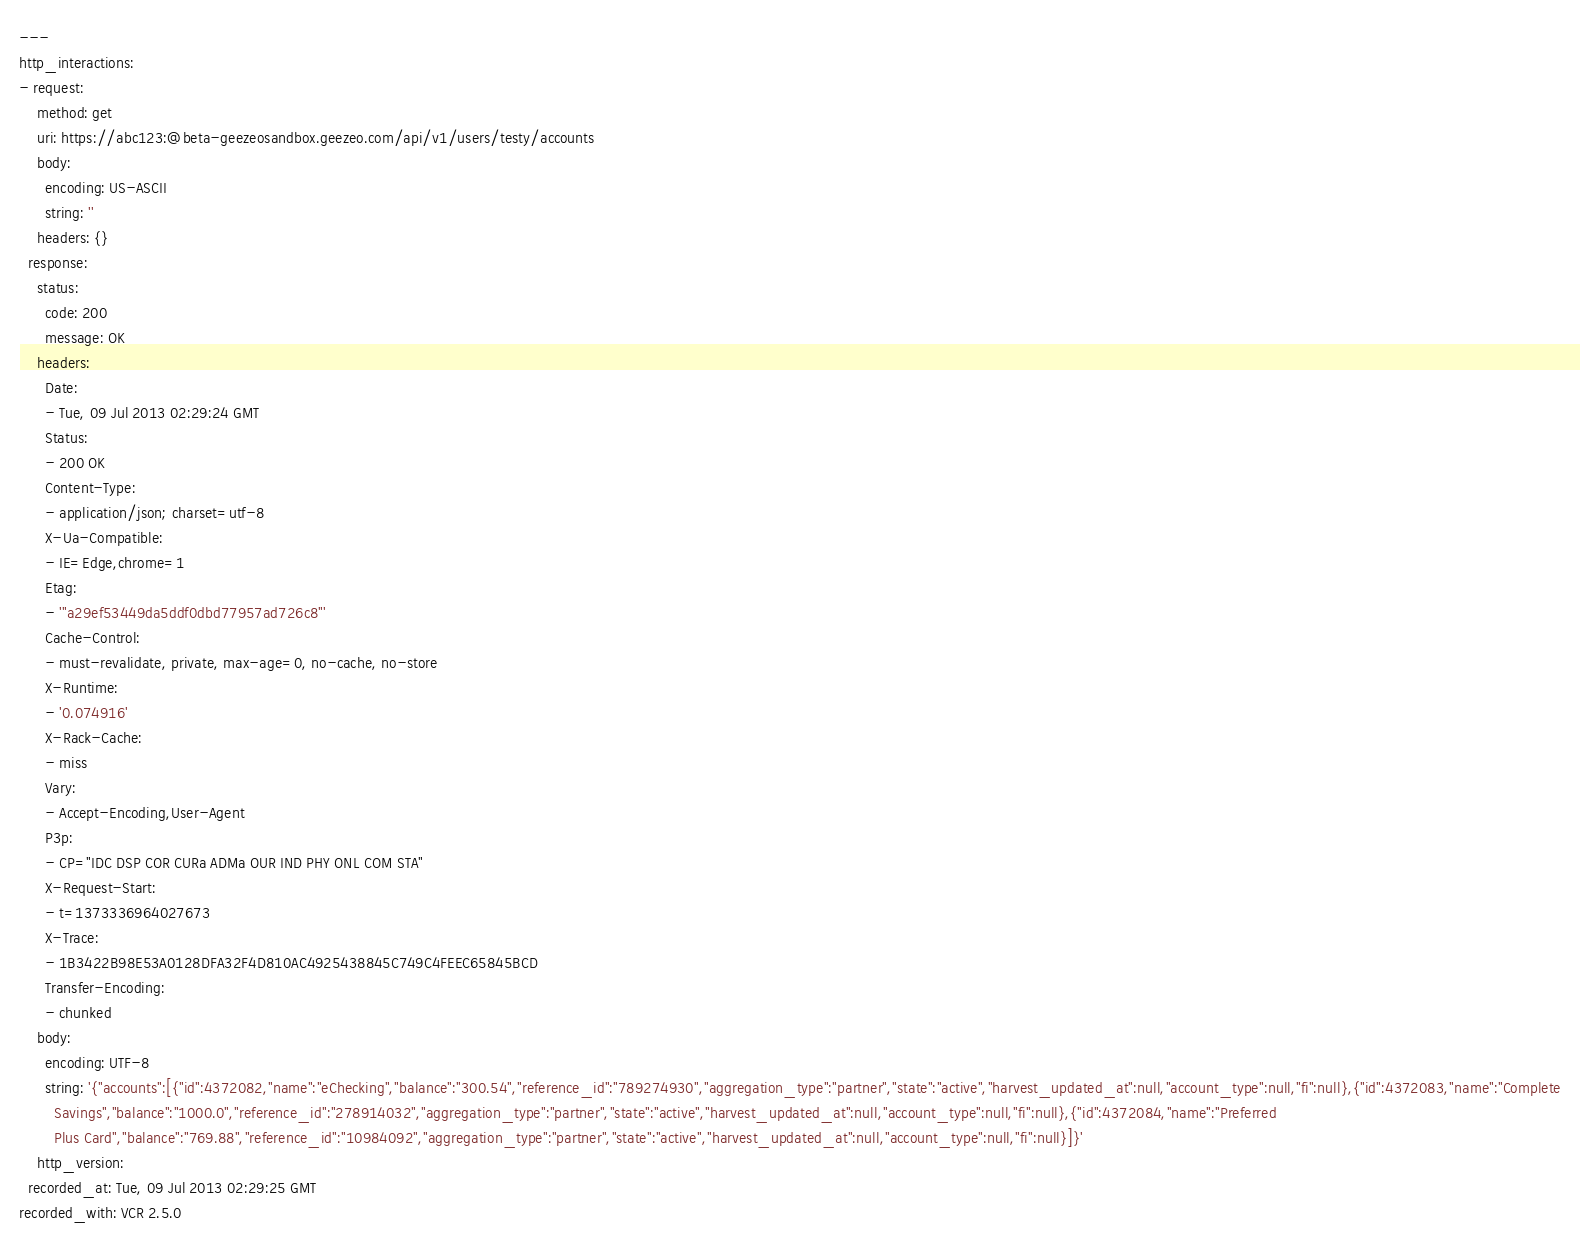Convert code to text. <code><loc_0><loc_0><loc_500><loc_500><_YAML_>---
http_interactions:
- request:
    method: get
    uri: https://abc123:@beta-geezeosandbox.geezeo.com/api/v1/users/testy/accounts
    body:
      encoding: US-ASCII
      string: ''
    headers: {}
  response:
    status:
      code: 200
      message: OK
    headers:
      Date:
      - Tue, 09 Jul 2013 02:29:24 GMT
      Status:
      - 200 OK
      Content-Type:
      - application/json; charset=utf-8
      X-Ua-Compatible:
      - IE=Edge,chrome=1
      Etag:
      - '"a29ef53449da5ddf0dbd77957ad726c8"'
      Cache-Control:
      - must-revalidate, private, max-age=0, no-cache, no-store
      X-Runtime:
      - '0.074916'
      X-Rack-Cache:
      - miss
      Vary:
      - Accept-Encoding,User-Agent
      P3p:
      - CP="IDC DSP COR CURa ADMa OUR IND PHY ONL COM STA"
      X-Request-Start:
      - t=1373336964027673
      X-Trace:
      - 1B3422B98E53A0128DFA32F4D810AC4925438845C749C4FEEC65845BCD
      Transfer-Encoding:
      - chunked
    body:
      encoding: UTF-8
      string: '{"accounts":[{"id":4372082,"name":"eChecking","balance":"300.54","reference_id":"789274930","aggregation_type":"partner","state":"active","harvest_updated_at":null,"account_type":null,"fi":null},{"id":4372083,"name":"Complete
        Savings","balance":"1000.0","reference_id":"278914032","aggregation_type":"partner","state":"active","harvest_updated_at":null,"account_type":null,"fi":null},{"id":4372084,"name":"Preferred
        Plus Card","balance":"769.88","reference_id":"10984092","aggregation_type":"partner","state":"active","harvest_updated_at":null,"account_type":null,"fi":null}]}'
    http_version: 
  recorded_at: Tue, 09 Jul 2013 02:29:25 GMT
recorded_with: VCR 2.5.0
</code> 